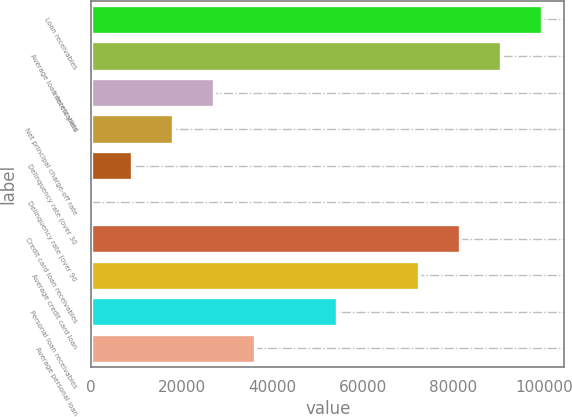Convert chart. <chart><loc_0><loc_0><loc_500><loc_500><bar_chart><fcel>Loan receivables<fcel>Average loan receivables<fcel>Interest yield<fcel>Net principal charge-off rate<fcel>Delinquency rate (over 30<fcel>Delinquency rate (over 90<fcel>Credit card loan receivables<fcel>Average credit card loan<fcel>Personal loan receivables<fcel>Average personal loan<nl><fcel>99563.1<fcel>90512<fcel>27154.3<fcel>18103.3<fcel>9052.17<fcel>1.08<fcel>81460.9<fcel>72409.8<fcel>54307.6<fcel>36205.4<nl></chart> 